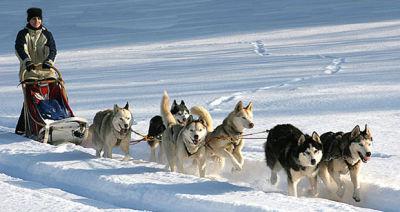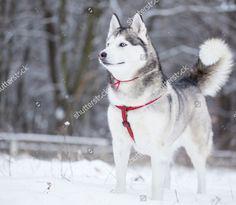The first image is the image on the left, the second image is the image on the right. Analyze the images presented: Is the assertion "one of the images contain only one wolf" valid? Answer yes or no. Yes. 